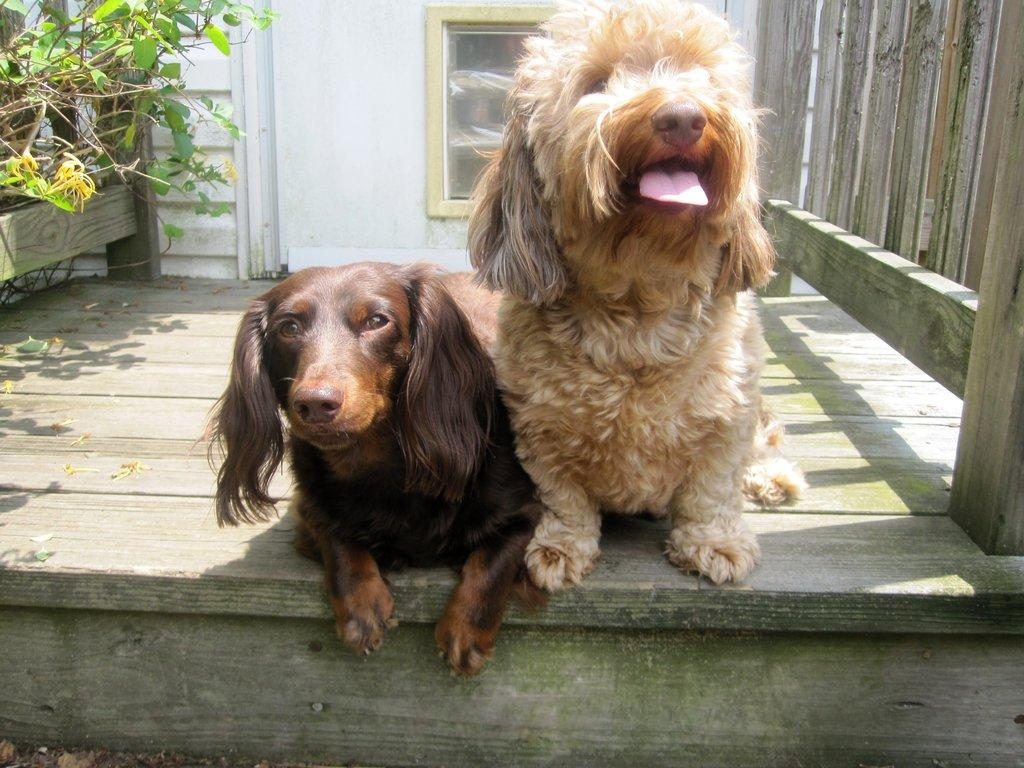What type of animals can be seen on the wooden floor in the image? There are animals on the wooden floor in the image. What material is the fencing in the image made of? The fencing in the image is made of wood. What other elements can be seen in the image besides the animals and fencing? There are plants and a wall with a door in the image. How many girls are present in the image? There is no mention of girls in the provided facts, so we cannot determine their presence in the image. 